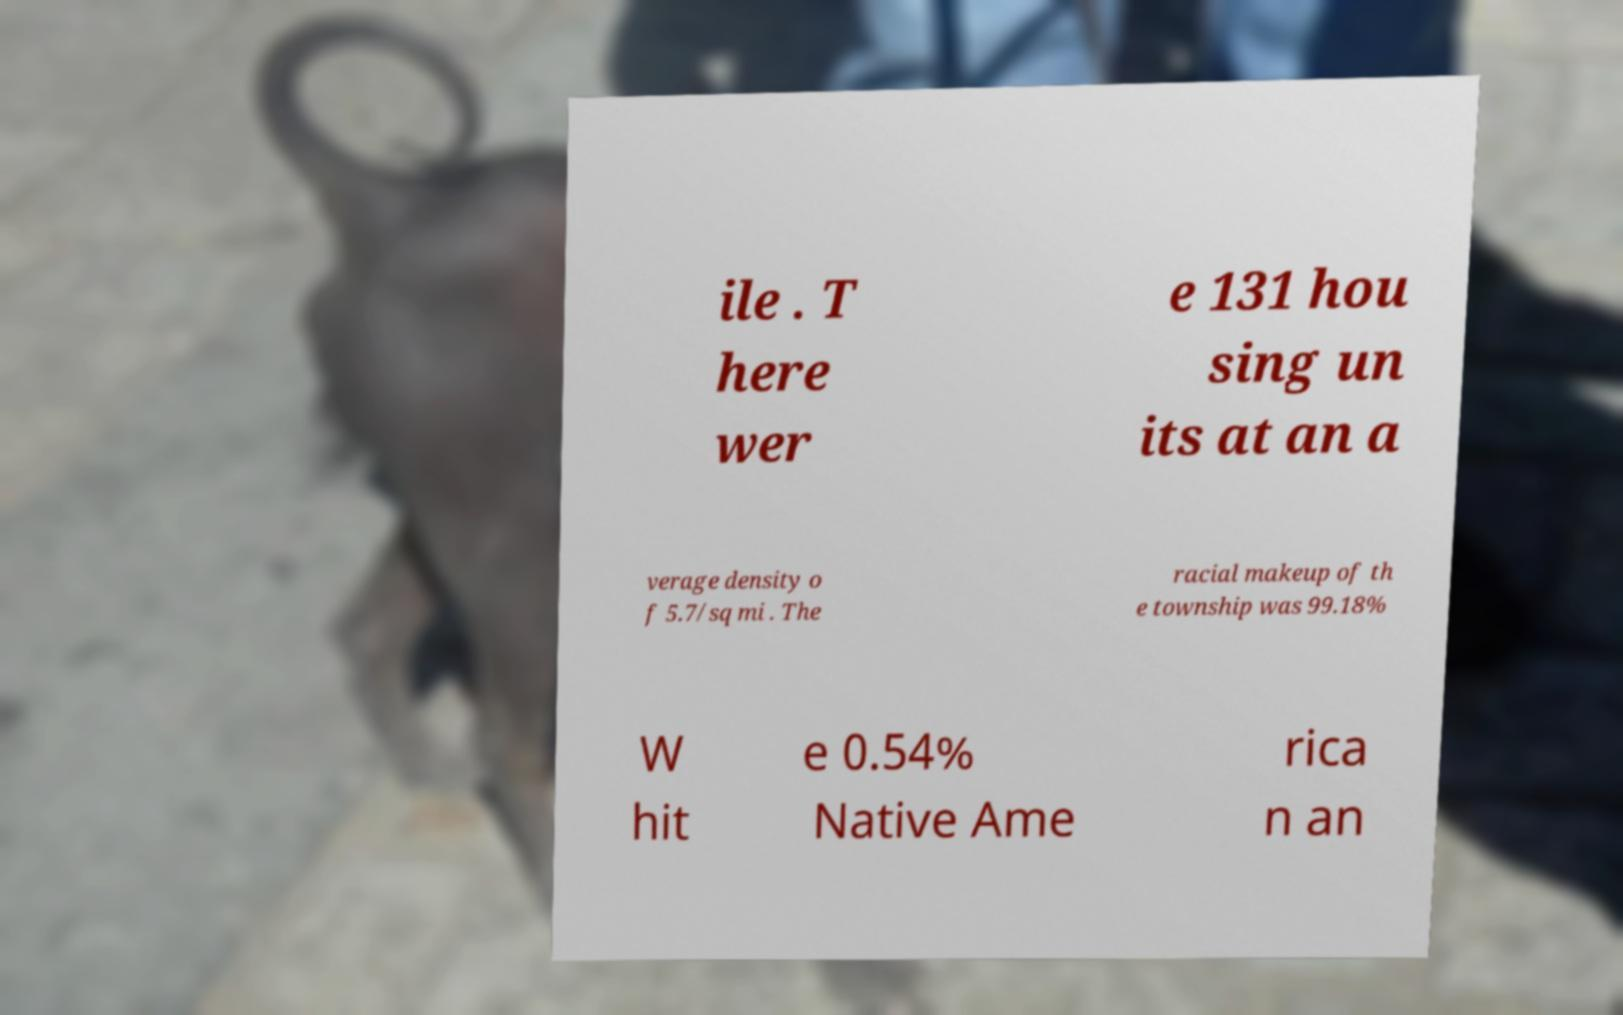I need the written content from this picture converted into text. Can you do that? ile . T here wer e 131 hou sing un its at an a verage density o f 5.7/sq mi . The racial makeup of th e township was 99.18% W hit e 0.54% Native Ame rica n an 